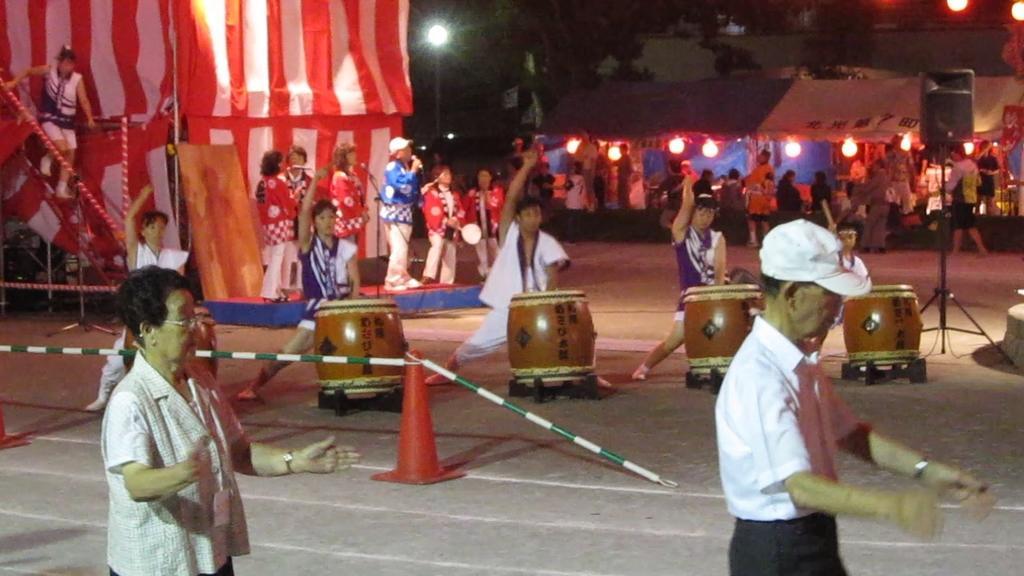In one or two sentences, can you explain what this image depicts? In this image I can see a five persons playing a drums on the road. At the back side there are few persons standing and holding a mic. At the back side I can see a tent,building and a trees. In front two persons are walking on the road. On the right side there is a speaker. 